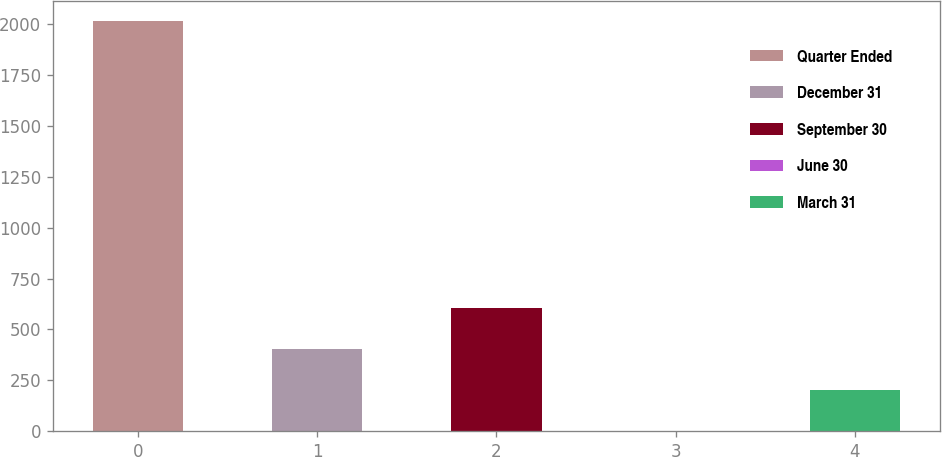Convert chart. <chart><loc_0><loc_0><loc_500><loc_500><bar_chart><fcel>Quarter Ended<fcel>December 31<fcel>September 30<fcel>June 30<fcel>March 31<nl><fcel>2012<fcel>402.54<fcel>603.72<fcel>0.18<fcel>201.36<nl></chart> 